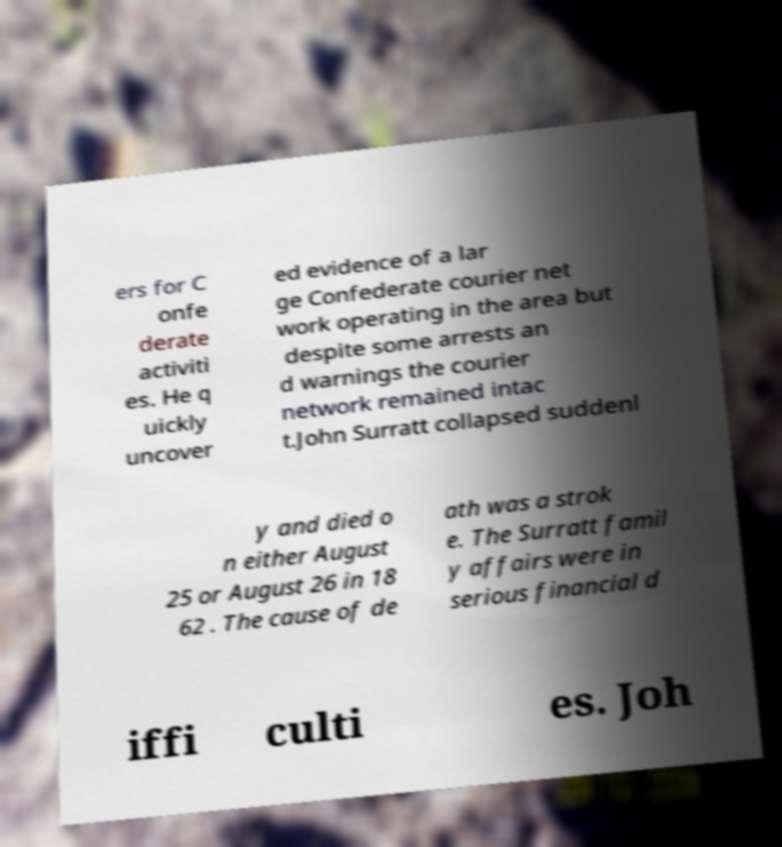Can you read and provide the text displayed in the image?This photo seems to have some interesting text. Can you extract and type it out for me? ers for C onfe derate activiti es. He q uickly uncover ed evidence of a lar ge Confederate courier net work operating in the area but despite some arrests an d warnings the courier network remained intac t.John Surratt collapsed suddenl y and died o n either August 25 or August 26 in 18 62 . The cause of de ath was a strok e. The Surratt famil y affairs were in serious financial d iffi culti es. Joh 